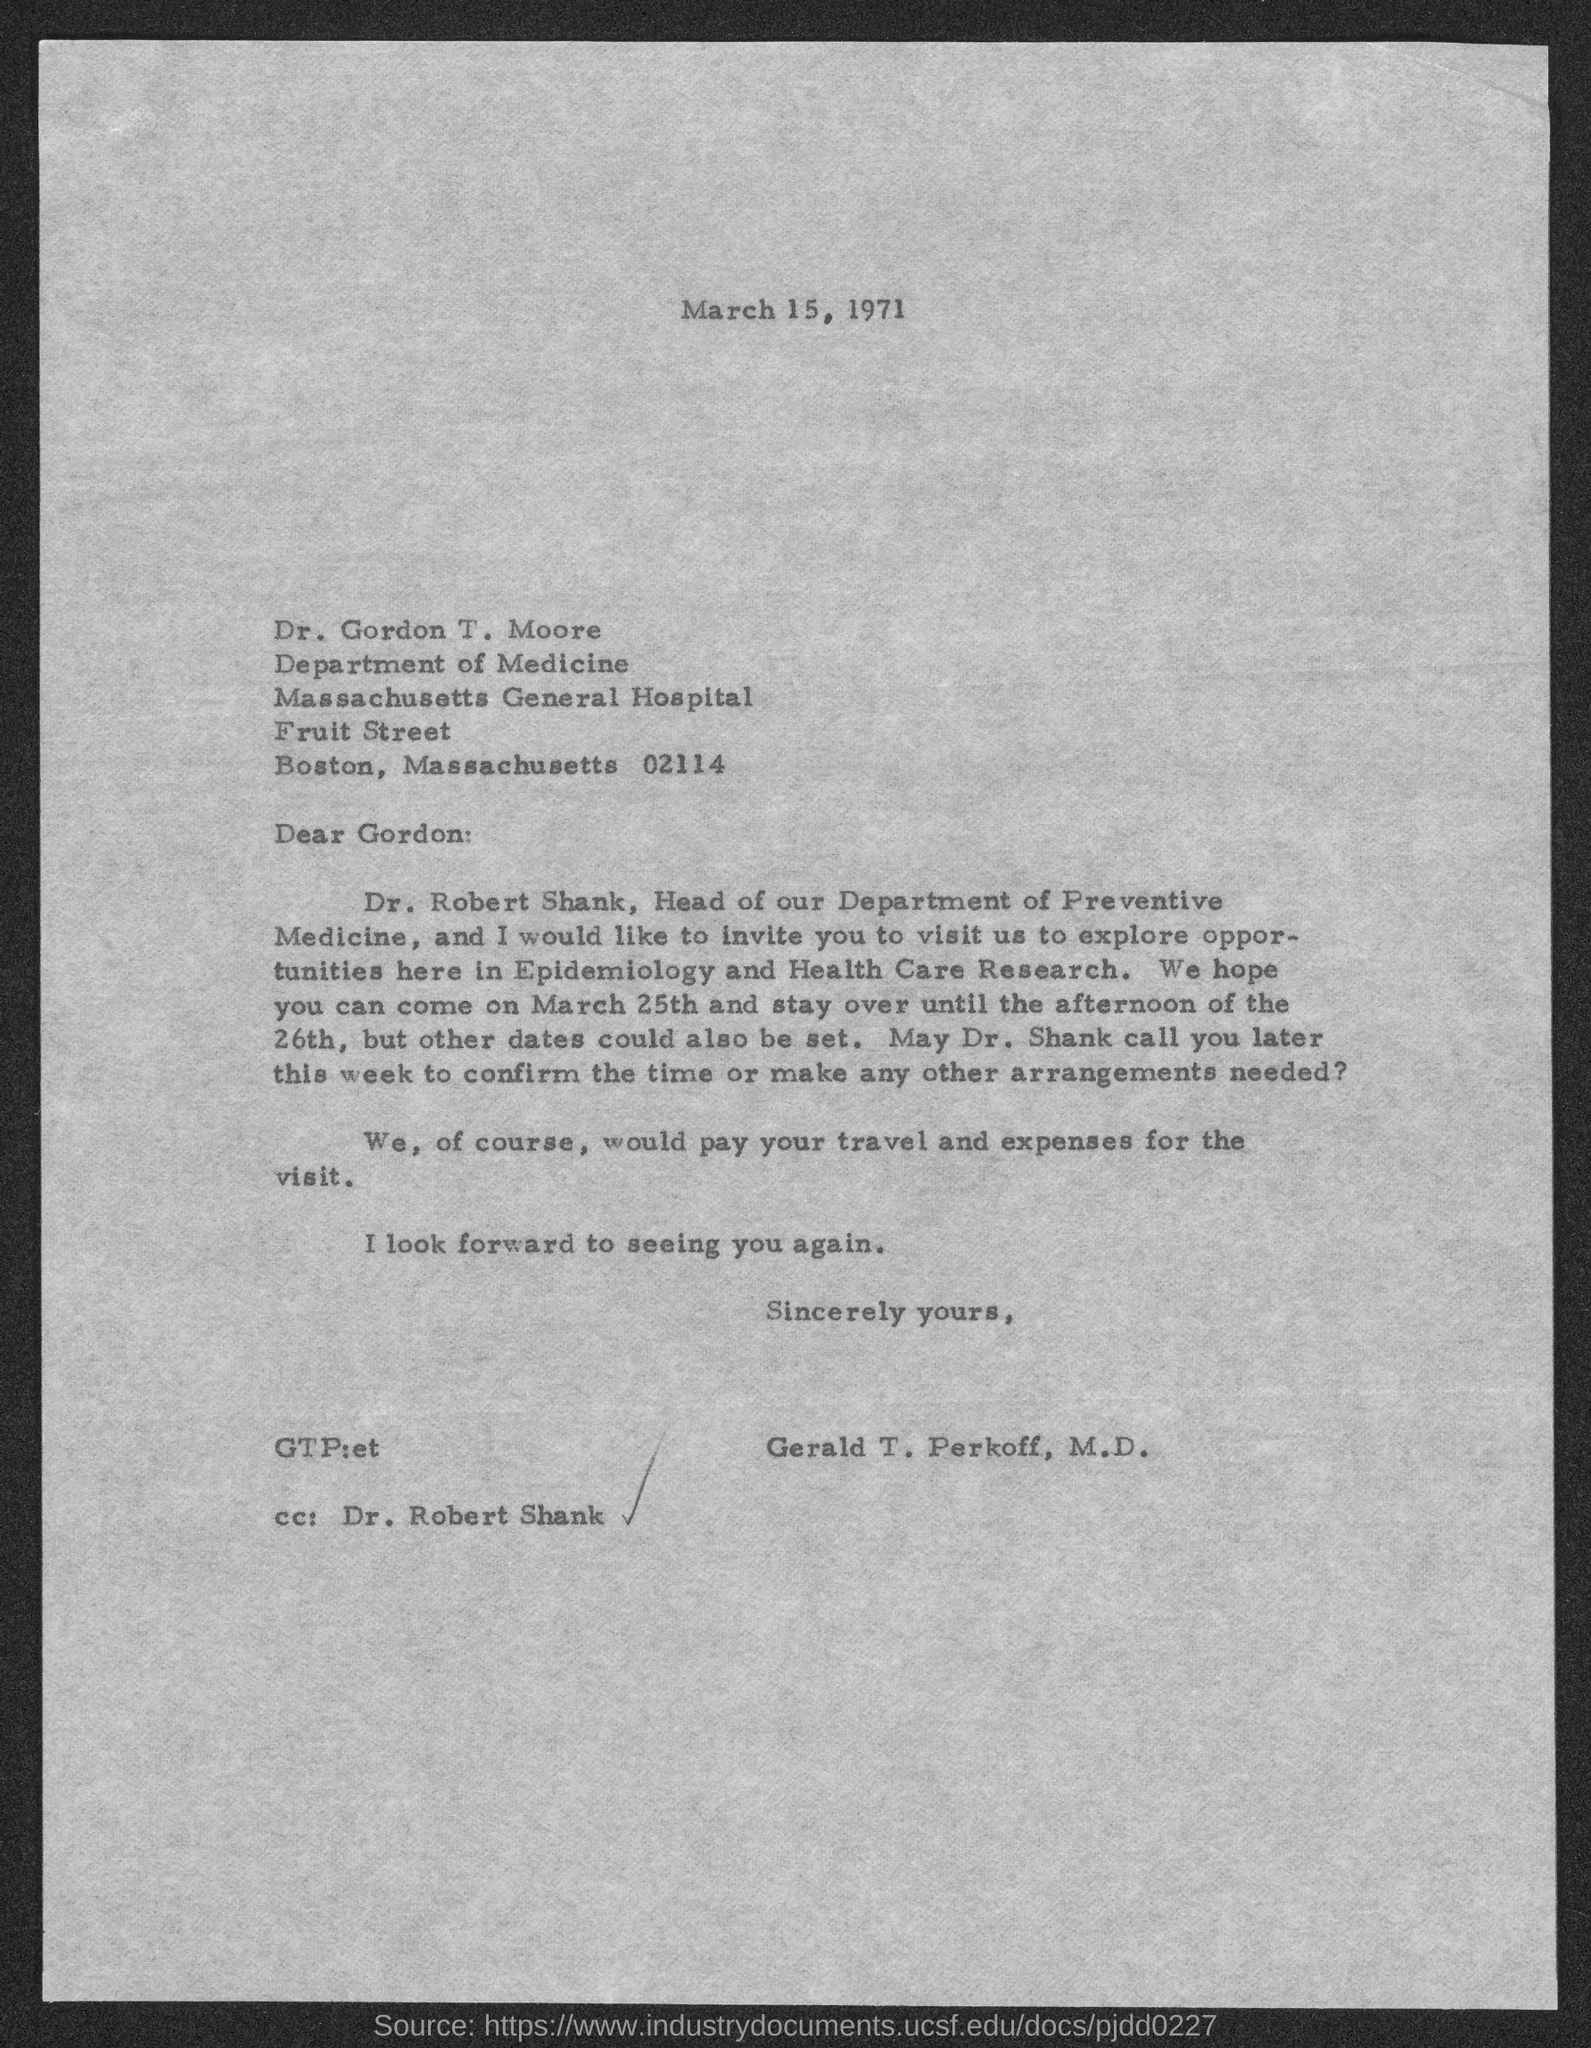To whom this letter is written to?
Give a very brief answer. Dr. Gordon T. Moore. What is the postalcode of massachusetts?
Ensure brevity in your answer.  02114. Who wrote this letter?
Your answer should be very brief. Gerald T. Perkoff, M.D. Who is the head of department of preventive medicine?
Give a very brief answer. Dr. Robert shank. 